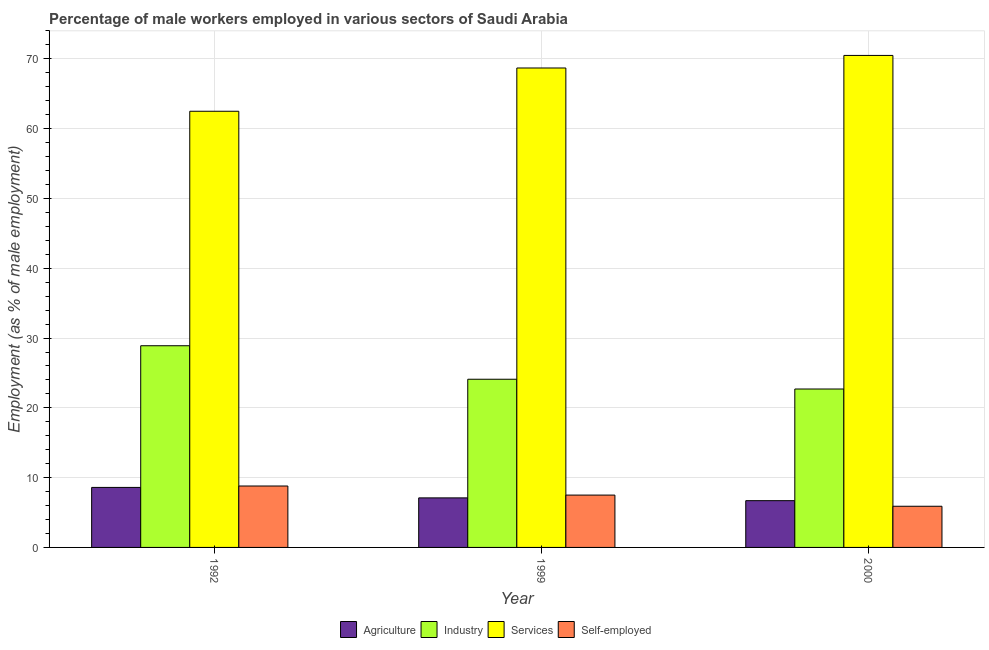How many different coloured bars are there?
Keep it short and to the point. 4. How many groups of bars are there?
Your answer should be very brief. 3. Are the number of bars per tick equal to the number of legend labels?
Ensure brevity in your answer.  Yes. Are the number of bars on each tick of the X-axis equal?
Ensure brevity in your answer.  Yes. How many bars are there on the 2nd tick from the left?
Keep it short and to the point. 4. How many bars are there on the 3rd tick from the right?
Your answer should be compact. 4. What is the label of the 1st group of bars from the left?
Your response must be concise. 1992. In how many cases, is the number of bars for a given year not equal to the number of legend labels?
Your response must be concise. 0. What is the percentage of male workers in industry in 1999?
Your answer should be very brief. 24.1. Across all years, what is the maximum percentage of male workers in industry?
Offer a very short reply. 28.9. Across all years, what is the minimum percentage of male workers in agriculture?
Ensure brevity in your answer.  6.7. What is the total percentage of male workers in industry in the graph?
Provide a short and direct response. 75.7. What is the difference between the percentage of male workers in industry in 1992 and that in 1999?
Give a very brief answer. 4.8. What is the difference between the percentage of male workers in industry in 1992 and the percentage of male workers in services in 2000?
Give a very brief answer. 6.2. What is the average percentage of male workers in agriculture per year?
Ensure brevity in your answer.  7.47. In how many years, is the percentage of male workers in services greater than 2 %?
Offer a terse response. 3. What is the ratio of the percentage of male workers in industry in 1992 to that in 1999?
Make the answer very short. 1.2. Is the percentage of self employed male workers in 1992 less than that in 2000?
Keep it short and to the point. No. What is the difference between the highest and the second highest percentage of male workers in services?
Provide a succinct answer. 1.8. What is the difference between the highest and the lowest percentage of male workers in industry?
Provide a succinct answer. 6.2. What does the 4th bar from the left in 1992 represents?
Make the answer very short. Self-employed. What does the 3rd bar from the right in 2000 represents?
Offer a very short reply. Industry. Are all the bars in the graph horizontal?
Make the answer very short. No. What is the difference between two consecutive major ticks on the Y-axis?
Your answer should be very brief. 10. Are the values on the major ticks of Y-axis written in scientific E-notation?
Your answer should be very brief. No. Where does the legend appear in the graph?
Provide a short and direct response. Bottom center. How many legend labels are there?
Provide a succinct answer. 4. How are the legend labels stacked?
Provide a succinct answer. Horizontal. What is the title of the graph?
Your answer should be very brief. Percentage of male workers employed in various sectors of Saudi Arabia. Does "Agriculture" appear as one of the legend labels in the graph?
Provide a short and direct response. Yes. What is the label or title of the X-axis?
Your response must be concise. Year. What is the label or title of the Y-axis?
Keep it short and to the point. Employment (as % of male employment). What is the Employment (as % of male employment) in Agriculture in 1992?
Provide a succinct answer. 8.6. What is the Employment (as % of male employment) of Industry in 1992?
Make the answer very short. 28.9. What is the Employment (as % of male employment) of Services in 1992?
Provide a succinct answer. 62.5. What is the Employment (as % of male employment) of Self-employed in 1992?
Give a very brief answer. 8.8. What is the Employment (as % of male employment) in Agriculture in 1999?
Make the answer very short. 7.1. What is the Employment (as % of male employment) in Industry in 1999?
Your response must be concise. 24.1. What is the Employment (as % of male employment) of Services in 1999?
Ensure brevity in your answer.  68.7. What is the Employment (as % of male employment) in Self-employed in 1999?
Your answer should be very brief. 7.5. What is the Employment (as % of male employment) of Agriculture in 2000?
Keep it short and to the point. 6.7. What is the Employment (as % of male employment) of Industry in 2000?
Your answer should be very brief. 22.7. What is the Employment (as % of male employment) in Services in 2000?
Your response must be concise. 70.5. What is the Employment (as % of male employment) of Self-employed in 2000?
Your answer should be compact. 5.9. Across all years, what is the maximum Employment (as % of male employment) in Agriculture?
Your answer should be very brief. 8.6. Across all years, what is the maximum Employment (as % of male employment) of Industry?
Keep it short and to the point. 28.9. Across all years, what is the maximum Employment (as % of male employment) in Services?
Your answer should be very brief. 70.5. Across all years, what is the maximum Employment (as % of male employment) in Self-employed?
Your response must be concise. 8.8. Across all years, what is the minimum Employment (as % of male employment) of Agriculture?
Give a very brief answer. 6.7. Across all years, what is the minimum Employment (as % of male employment) of Industry?
Make the answer very short. 22.7. Across all years, what is the minimum Employment (as % of male employment) in Services?
Provide a short and direct response. 62.5. Across all years, what is the minimum Employment (as % of male employment) in Self-employed?
Your response must be concise. 5.9. What is the total Employment (as % of male employment) of Agriculture in the graph?
Give a very brief answer. 22.4. What is the total Employment (as % of male employment) of Industry in the graph?
Provide a short and direct response. 75.7. What is the total Employment (as % of male employment) of Services in the graph?
Give a very brief answer. 201.7. What is the total Employment (as % of male employment) of Self-employed in the graph?
Offer a terse response. 22.2. What is the difference between the Employment (as % of male employment) of Industry in 1992 and that in 1999?
Offer a very short reply. 4.8. What is the difference between the Employment (as % of male employment) of Self-employed in 1992 and that in 1999?
Your answer should be compact. 1.3. What is the difference between the Employment (as % of male employment) in Services in 1992 and that in 2000?
Provide a succinct answer. -8. What is the difference between the Employment (as % of male employment) of Self-employed in 1992 and that in 2000?
Ensure brevity in your answer.  2.9. What is the difference between the Employment (as % of male employment) in Services in 1999 and that in 2000?
Your answer should be very brief. -1.8. What is the difference between the Employment (as % of male employment) in Self-employed in 1999 and that in 2000?
Your response must be concise. 1.6. What is the difference between the Employment (as % of male employment) of Agriculture in 1992 and the Employment (as % of male employment) of Industry in 1999?
Ensure brevity in your answer.  -15.5. What is the difference between the Employment (as % of male employment) in Agriculture in 1992 and the Employment (as % of male employment) in Services in 1999?
Make the answer very short. -60.1. What is the difference between the Employment (as % of male employment) in Industry in 1992 and the Employment (as % of male employment) in Services in 1999?
Provide a short and direct response. -39.8. What is the difference between the Employment (as % of male employment) of Industry in 1992 and the Employment (as % of male employment) of Self-employed in 1999?
Give a very brief answer. 21.4. What is the difference between the Employment (as % of male employment) of Services in 1992 and the Employment (as % of male employment) of Self-employed in 1999?
Your answer should be very brief. 55. What is the difference between the Employment (as % of male employment) of Agriculture in 1992 and the Employment (as % of male employment) of Industry in 2000?
Offer a terse response. -14.1. What is the difference between the Employment (as % of male employment) of Agriculture in 1992 and the Employment (as % of male employment) of Services in 2000?
Offer a very short reply. -61.9. What is the difference between the Employment (as % of male employment) of Industry in 1992 and the Employment (as % of male employment) of Services in 2000?
Provide a short and direct response. -41.6. What is the difference between the Employment (as % of male employment) in Industry in 1992 and the Employment (as % of male employment) in Self-employed in 2000?
Your answer should be compact. 23. What is the difference between the Employment (as % of male employment) in Services in 1992 and the Employment (as % of male employment) in Self-employed in 2000?
Your answer should be compact. 56.6. What is the difference between the Employment (as % of male employment) in Agriculture in 1999 and the Employment (as % of male employment) in Industry in 2000?
Offer a very short reply. -15.6. What is the difference between the Employment (as % of male employment) of Agriculture in 1999 and the Employment (as % of male employment) of Services in 2000?
Your response must be concise. -63.4. What is the difference between the Employment (as % of male employment) of Agriculture in 1999 and the Employment (as % of male employment) of Self-employed in 2000?
Your response must be concise. 1.2. What is the difference between the Employment (as % of male employment) of Industry in 1999 and the Employment (as % of male employment) of Services in 2000?
Provide a short and direct response. -46.4. What is the difference between the Employment (as % of male employment) in Industry in 1999 and the Employment (as % of male employment) in Self-employed in 2000?
Ensure brevity in your answer.  18.2. What is the difference between the Employment (as % of male employment) of Services in 1999 and the Employment (as % of male employment) of Self-employed in 2000?
Offer a very short reply. 62.8. What is the average Employment (as % of male employment) in Agriculture per year?
Ensure brevity in your answer.  7.47. What is the average Employment (as % of male employment) of Industry per year?
Your answer should be very brief. 25.23. What is the average Employment (as % of male employment) in Services per year?
Your response must be concise. 67.23. In the year 1992, what is the difference between the Employment (as % of male employment) of Agriculture and Employment (as % of male employment) of Industry?
Offer a very short reply. -20.3. In the year 1992, what is the difference between the Employment (as % of male employment) of Agriculture and Employment (as % of male employment) of Services?
Ensure brevity in your answer.  -53.9. In the year 1992, what is the difference between the Employment (as % of male employment) of Agriculture and Employment (as % of male employment) of Self-employed?
Offer a terse response. -0.2. In the year 1992, what is the difference between the Employment (as % of male employment) in Industry and Employment (as % of male employment) in Services?
Your response must be concise. -33.6. In the year 1992, what is the difference between the Employment (as % of male employment) of Industry and Employment (as % of male employment) of Self-employed?
Keep it short and to the point. 20.1. In the year 1992, what is the difference between the Employment (as % of male employment) of Services and Employment (as % of male employment) of Self-employed?
Offer a terse response. 53.7. In the year 1999, what is the difference between the Employment (as % of male employment) of Agriculture and Employment (as % of male employment) of Industry?
Keep it short and to the point. -17. In the year 1999, what is the difference between the Employment (as % of male employment) in Agriculture and Employment (as % of male employment) in Services?
Your answer should be very brief. -61.6. In the year 1999, what is the difference between the Employment (as % of male employment) in Industry and Employment (as % of male employment) in Services?
Provide a succinct answer. -44.6. In the year 1999, what is the difference between the Employment (as % of male employment) in Services and Employment (as % of male employment) in Self-employed?
Offer a very short reply. 61.2. In the year 2000, what is the difference between the Employment (as % of male employment) in Agriculture and Employment (as % of male employment) in Services?
Provide a short and direct response. -63.8. In the year 2000, what is the difference between the Employment (as % of male employment) in Industry and Employment (as % of male employment) in Services?
Your answer should be compact. -47.8. In the year 2000, what is the difference between the Employment (as % of male employment) of Services and Employment (as % of male employment) of Self-employed?
Provide a short and direct response. 64.6. What is the ratio of the Employment (as % of male employment) of Agriculture in 1992 to that in 1999?
Give a very brief answer. 1.21. What is the ratio of the Employment (as % of male employment) in Industry in 1992 to that in 1999?
Your response must be concise. 1.2. What is the ratio of the Employment (as % of male employment) in Services in 1992 to that in 1999?
Provide a short and direct response. 0.91. What is the ratio of the Employment (as % of male employment) in Self-employed in 1992 to that in 1999?
Make the answer very short. 1.17. What is the ratio of the Employment (as % of male employment) of Agriculture in 1992 to that in 2000?
Your answer should be very brief. 1.28. What is the ratio of the Employment (as % of male employment) of Industry in 1992 to that in 2000?
Provide a short and direct response. 1.27. What is the ratio of the Employment (as % of male employment) of Services in 1992 to that in 2000?
Offer a terse response. 0.89. What is the ratio of the Employment (as % of male employment) in Self-employed in 1992 to that in 2000?
Make the answer very short. 1.49. What is the ratio of the Employment (as % of male employment) in Agriculture in 1999 to that in 2000?
Provide a short and direct response. 1.06. What is the ratio of the Employment (as % of male employment) in Industry in 1999 to that in 2000?
Provide a short and direct response. 1.06. What is the ratio of the Employment (as % of male employment) of Services in 1999 to that in 2000?
Your response must be concise. 0.97. What is the ratio of the Employment (as % of male employment) of Self-employed in 1999 to that in 2000?
Offer a terse response. 1.27. What is the difference between the highest and the second highest Employment (as % of male employment) of Agriculture?
Make the answer very short. 1.5. What is the difference between the highest and the second highest Employment (as % of male employment) of Industry?
Provide a succinct answer. 4.8. 